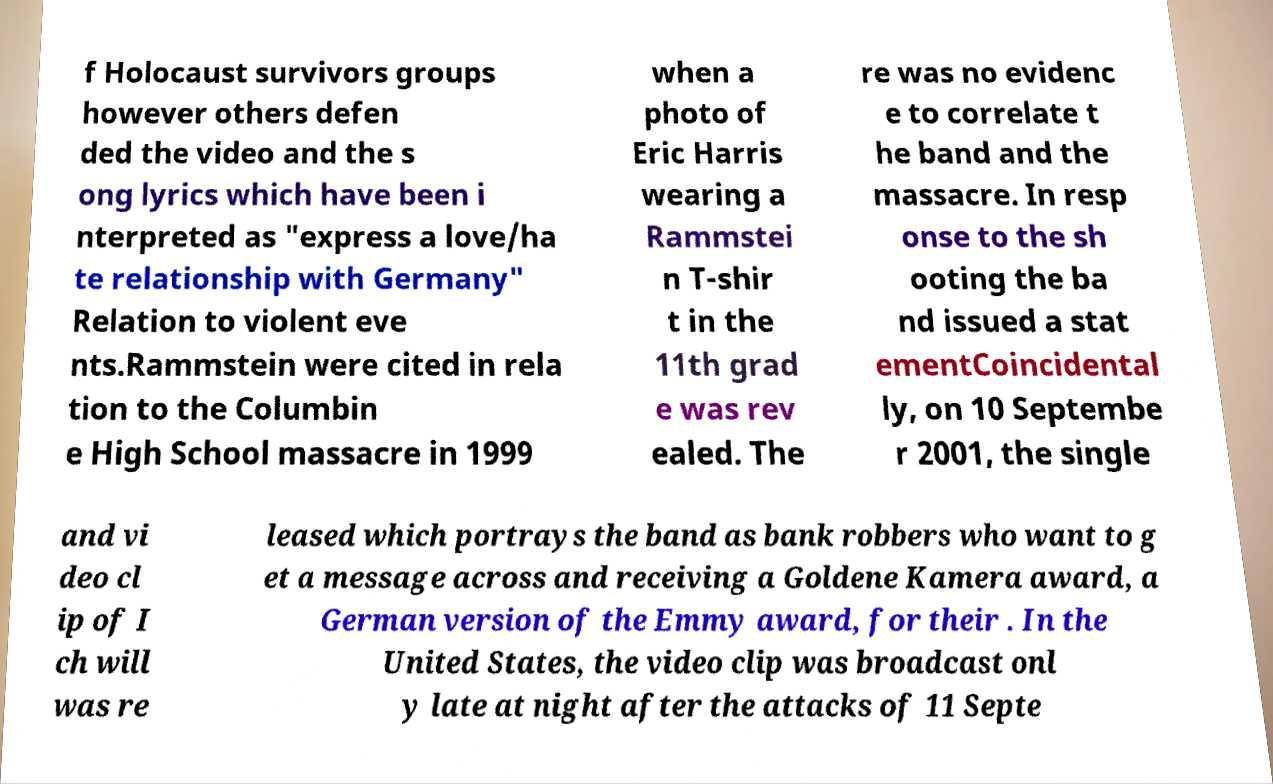Could you assist in decoding the text presented in this image and type it out clearly? f Holocaust survivors groups however others defen ded the video and the s ong lyrics which have been i nterpreted as "express a love/ha te relationship with Germany" Relation to violent eve nts.Rammstein were cited in rela tion to the Columbin e High School massacre in 1999 when a photo of Eric Harris wearing a Rammstei n T-shir t in the 11th grad e was rev ealed. The re was no evidenc e to correlate t he band and the massacre. In resp onse to the sh ooting the ba nd issued a stat ementCoincidental ly, on 10 Septembe r 2001, the single and vi deo cl ip of I ch will was re leased which portrays the band as bank robbers who want to g et a message across and receiving a Goldene Kamera award, a German version of the Emmy award, for their . In the United States, the video clip was broadcast onl y late at night after the attacks of 11 Septe 